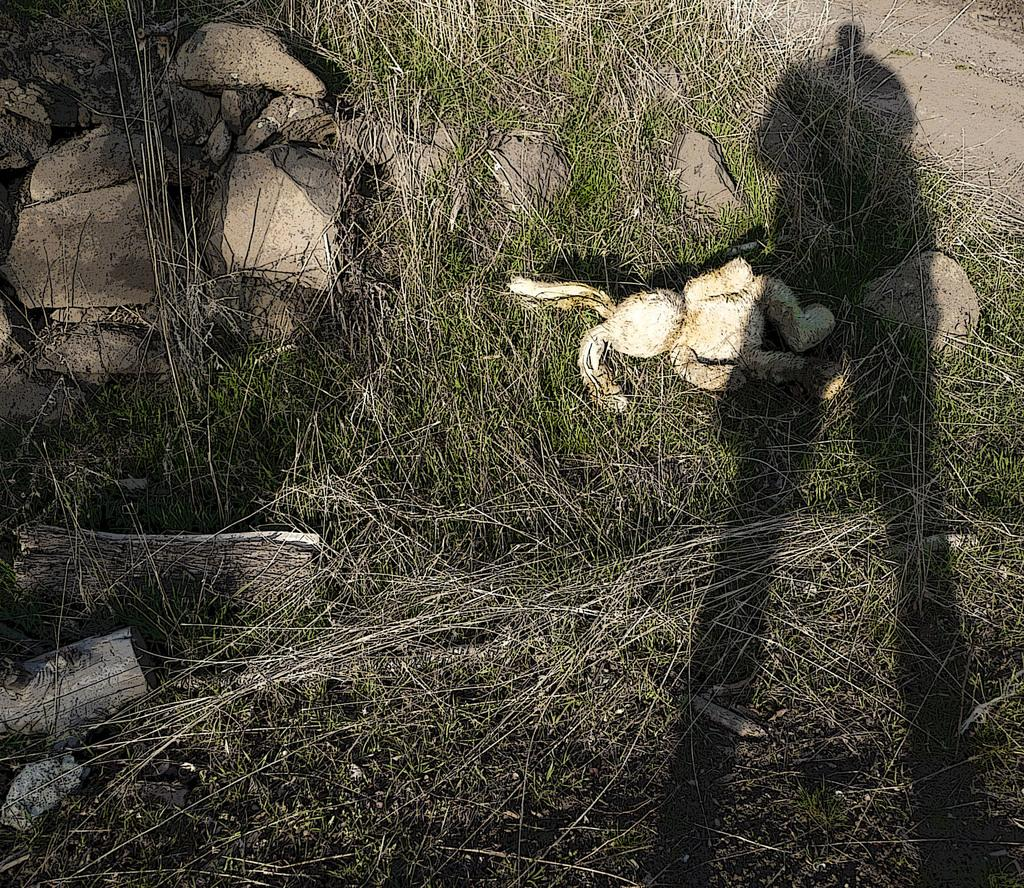What can be seen in the image that indicates the presence of a person? There is a shadow of a person in the image. What type of natural environment is visible in the image? There is grass visible in the image. What materials are the wooden logs made of? The wooden logs are made of wood. What type of ground surface is visible in the image? There are stones in the image. What is the white object on the grass? It is not specified what the white object on the grass is. What is the path visible in the image used for? The path visible in the bottom right of the image is likely used for walking or traveling through the area. What type of calculator can be seen on the grass in the image? There is no calculator present in the image. What type of meal is being prepared on the wooden logs in the image? There is no meal being prepared in the image; the wooden logs are simply present in the scene. 